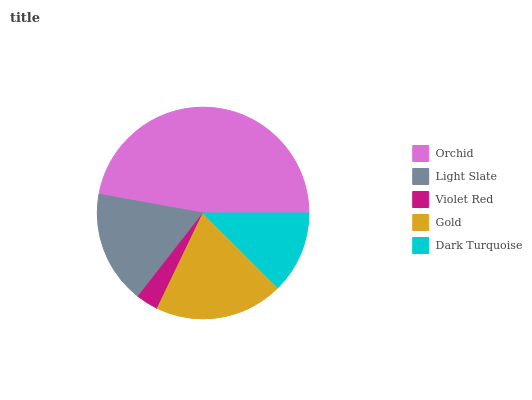Is Violet Red the minimum?
Answer yes or no. Yes. Is Orchid the maximum?
Answer yes or no. Yes. Is Light Slate the minimum?
Answer yes or no. No. Is Light Slate the maximum?
Answer yes or no. No. Is Orchid greater than Light Slate?
Answer yes or no. Yes. Is Light Slate less than Orchid?
Answer yes or no. Yes. Is Light Slate greater than Orchid?
Answer yes or no. No. Is Orchid less than Light Slate?
Answer yes or no. No. Is Light Slate the high median?
Answer yes or no. Yes. Is Light Slate the low median?
Answer yes or no. Yes. Is Orchid the high median?
Answer yes or no. No. Is Orchid the low median?
Answer yes or no. No. 